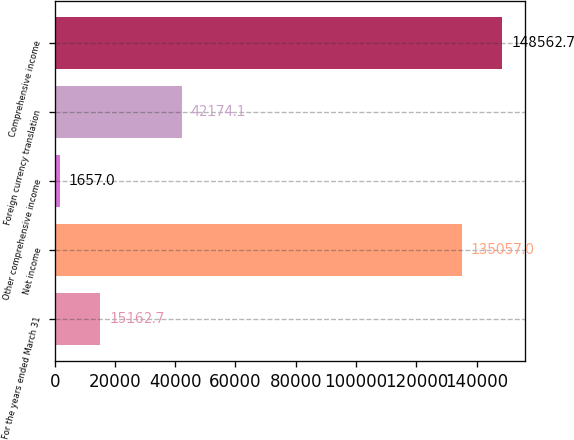<chart> <loc_0><loc_0><loc_500><loc_500><bar_chart><fcel>For the years ended March 31<fcel>Net income<fcel>Other comprehensive income<fcel>Foreign currency translation<fcel>Comprehensive income<nl><fcel>15162.7<fcel>135057<fcel>1657<fcel>42174.1<fcel>148563<nl></chart> 